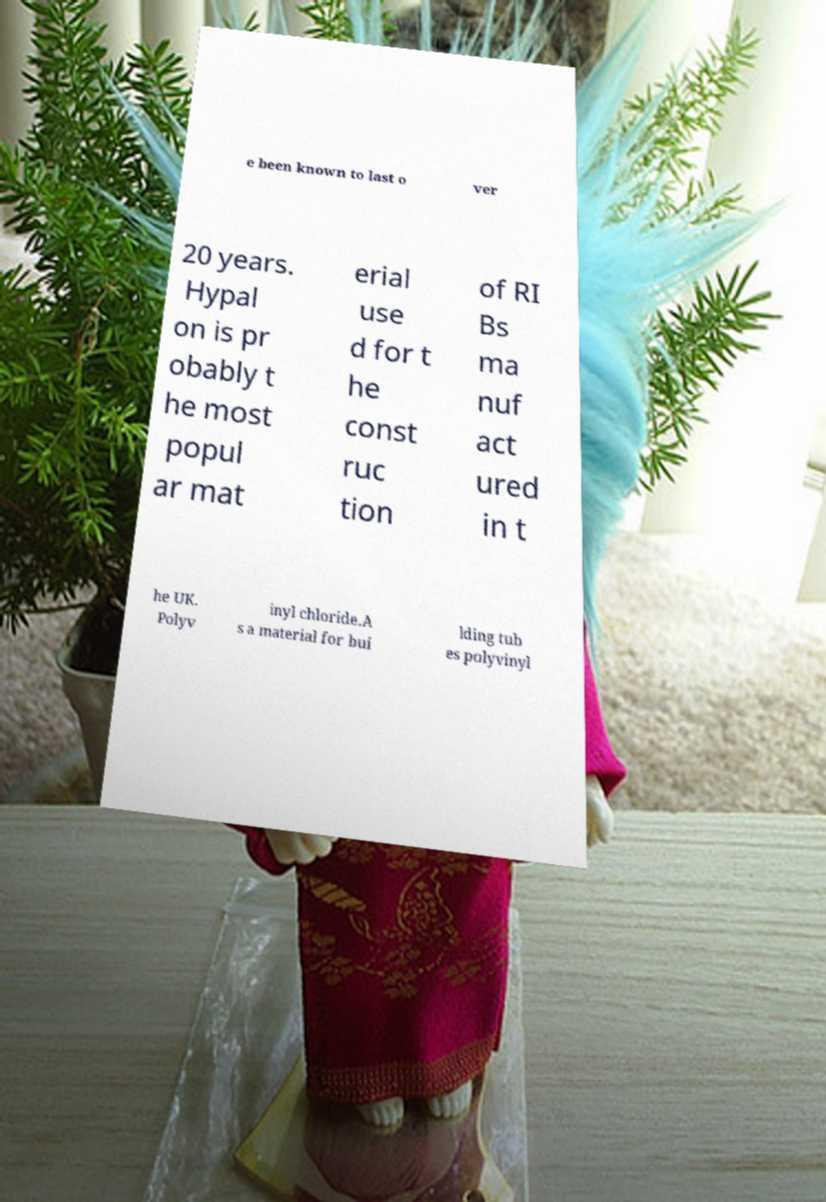For documentation purposes, I need the text within this image transcribed. Could you provide that? e been known to last o ver 20 years. Hypal on is pr obably t he most popul ar mat erial use d for t he const ruc tion of RI Bs ma nuf act ured in t he UK. Polyv inyl chloride.A s a material for bui lding tub es polyvinyl 